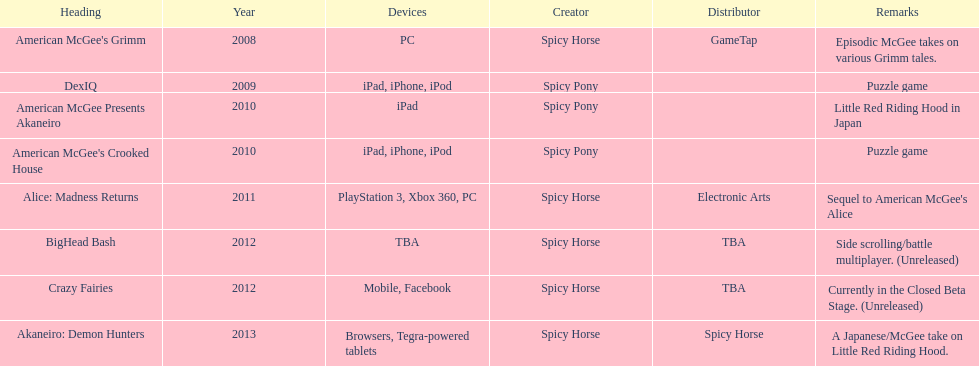What is the first title on this chart? American McGee's Grimm. 